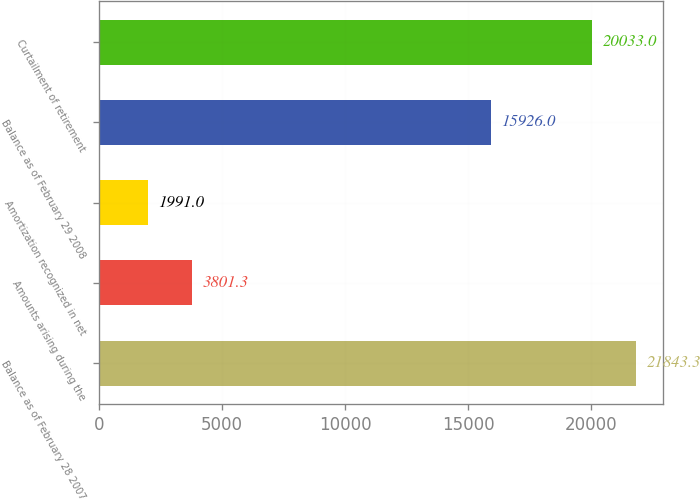<chart> <loc_0><loc_0><loc_500><loc_500><bar_chart><fcel>Balance as of February 28 2007<fcel>Amounts arising during the<fcel>Amortization recognized in net<fcel>Balance as of February 29 2008<fcel>Curtailment of retirement<nl><fcel>21843.3<fcel>3801.3<fcel>1991<fcel>15926<fcel>20033<nl></chart> 